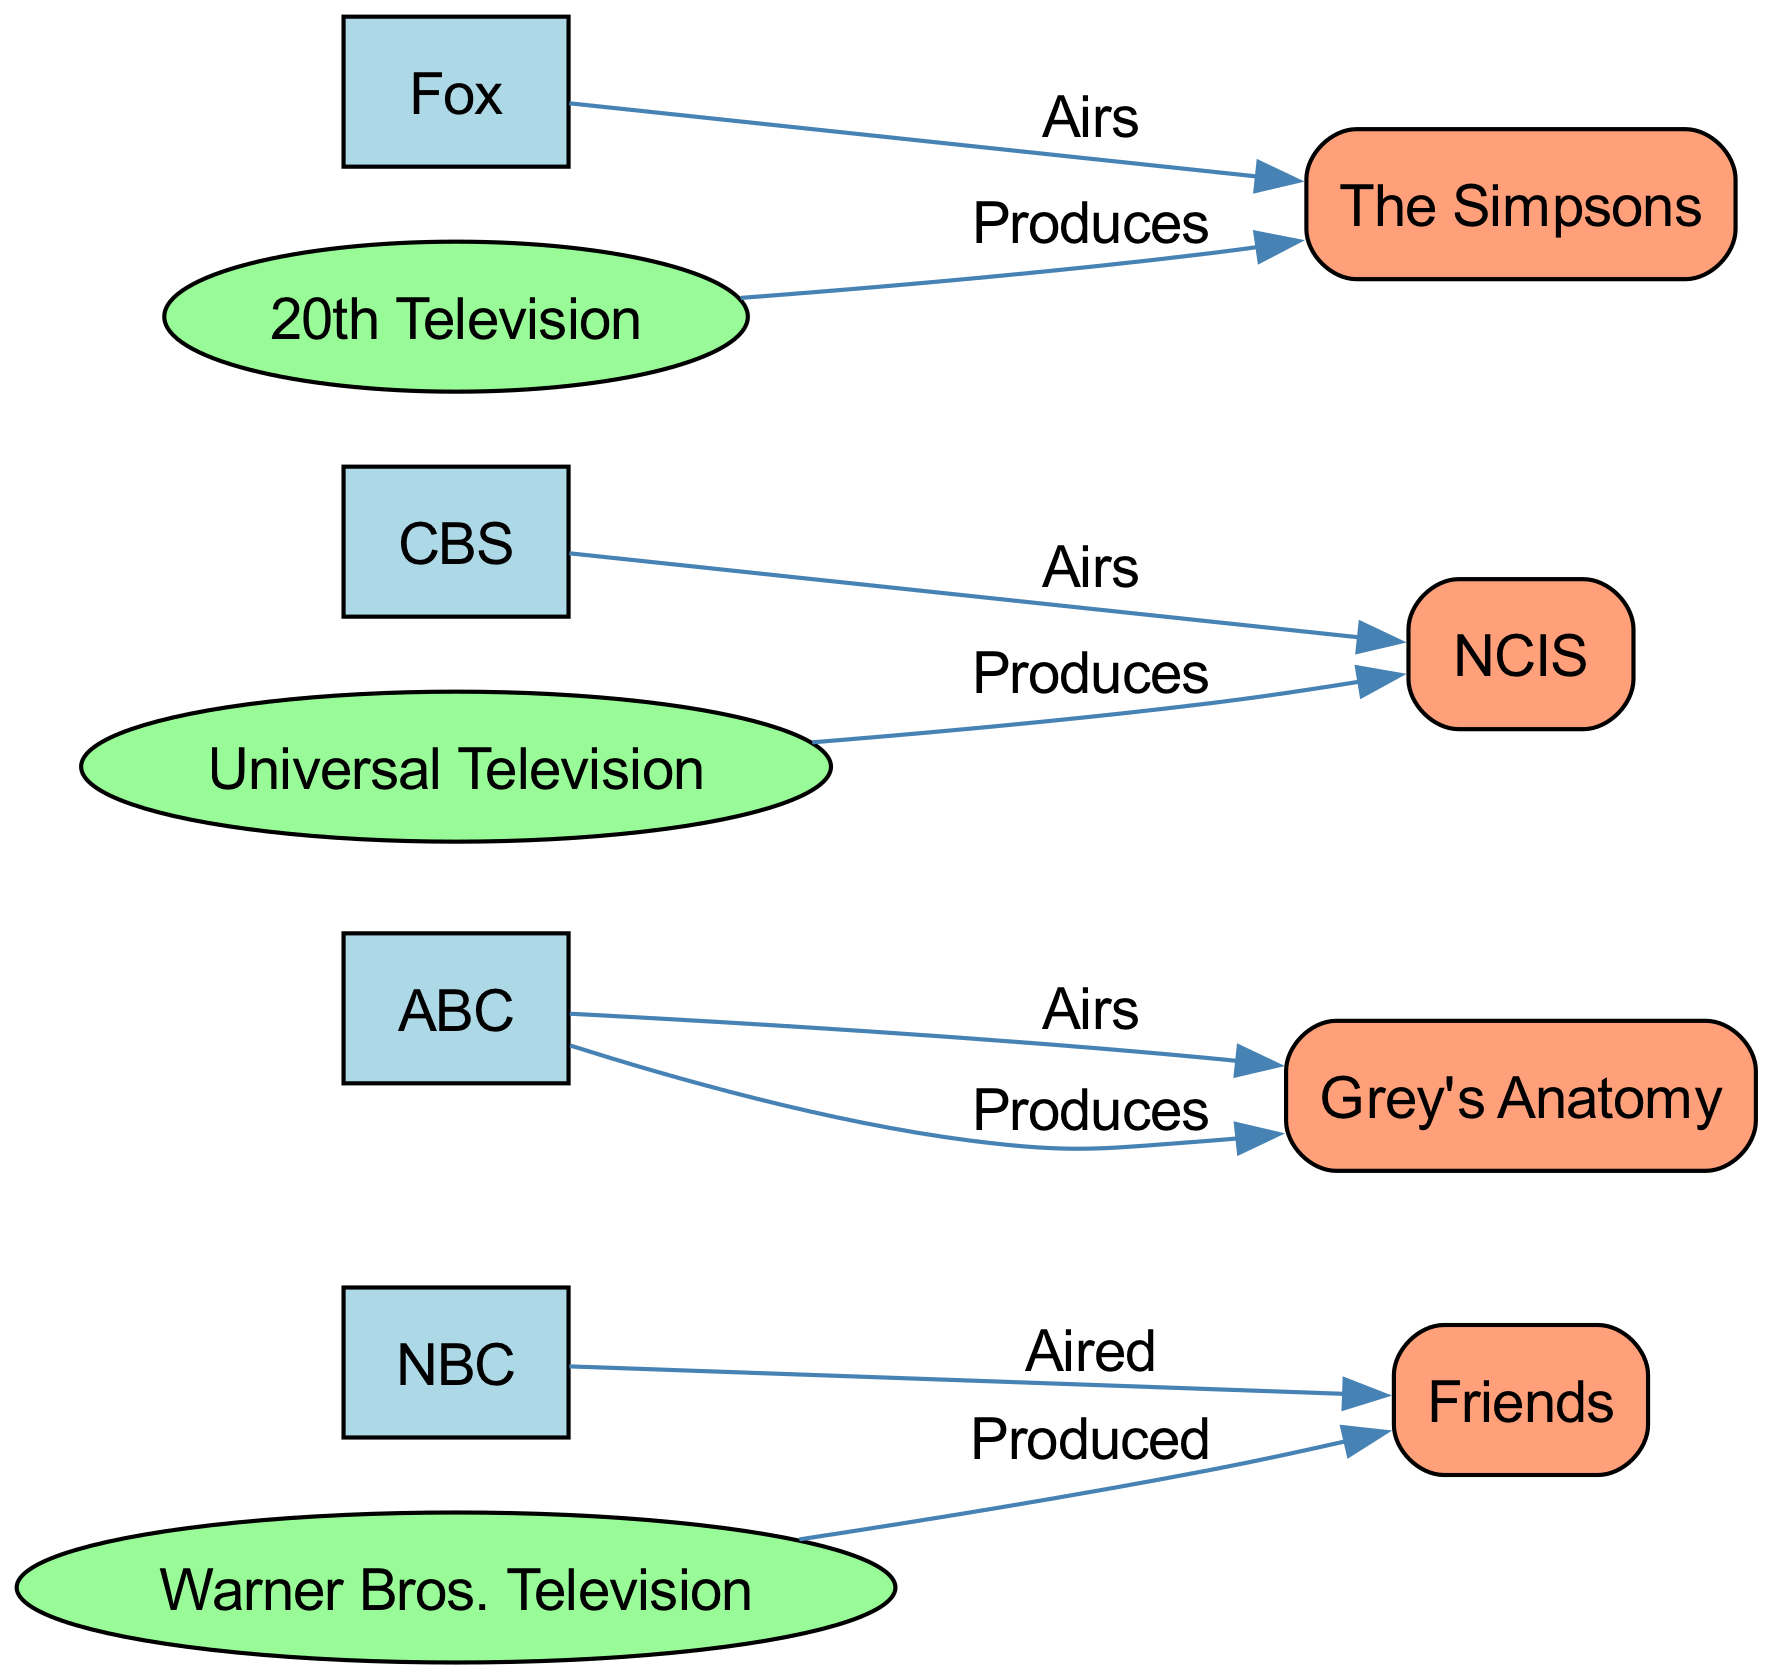What is the total number of nodes in the diagram? The diagram contains a total of 8 nodes: 4 networks, 3 production companies, and 1 show, which counts as a single node.
Answer: 8 Which network is associated with the show "Friends"? The edge from the node "NBC" to the node "Friends" indicates that NBC aired Friends, establishing their relationship.
Answer: NBC How many shows are produced by "Warner Bros. Television"? The edge from "Warner Bros. Television" to "Friends" indicates that Friends is produced by Warner Bros., signifying one show produced by this company.
Answer: 1 Which production company produces "The Simpsons"? The connection from "20th Television" to "The Simpsons" shows that this company is responsible for the production of the show.
Answer: 20th Television Which network airs "Grey's Anatomy"? The connection from "ABC" to "Grey's Anatomy" shows that ABC is the network that airs this show.
Answer: ABC Which two networks are involved with "NCIS"? "NCIS" has one direct relationship with "CBS", which airs it, and another indirect route through "Universal Television," which produces it, but does not directly link to a network. Overall, only CBS directly airs it
Answer: CBS Which show is associated with both "NBC" and "Warner Bros. Television"? The diagram displays an edge from NBC to Friends (indicating airing) and another from Warner Bros. Television to Friends (indicating production), thus linking both to Friends.
Answer: Friends What type of relationship exists between "ABC" and "Grey's Anatomy"? The edge from "ABC" to "Grey's Anatomy" labeled "Airs" denotes that ABC is the broadcaster of this show, illustrating a airing relationship.
Answer: Airs 